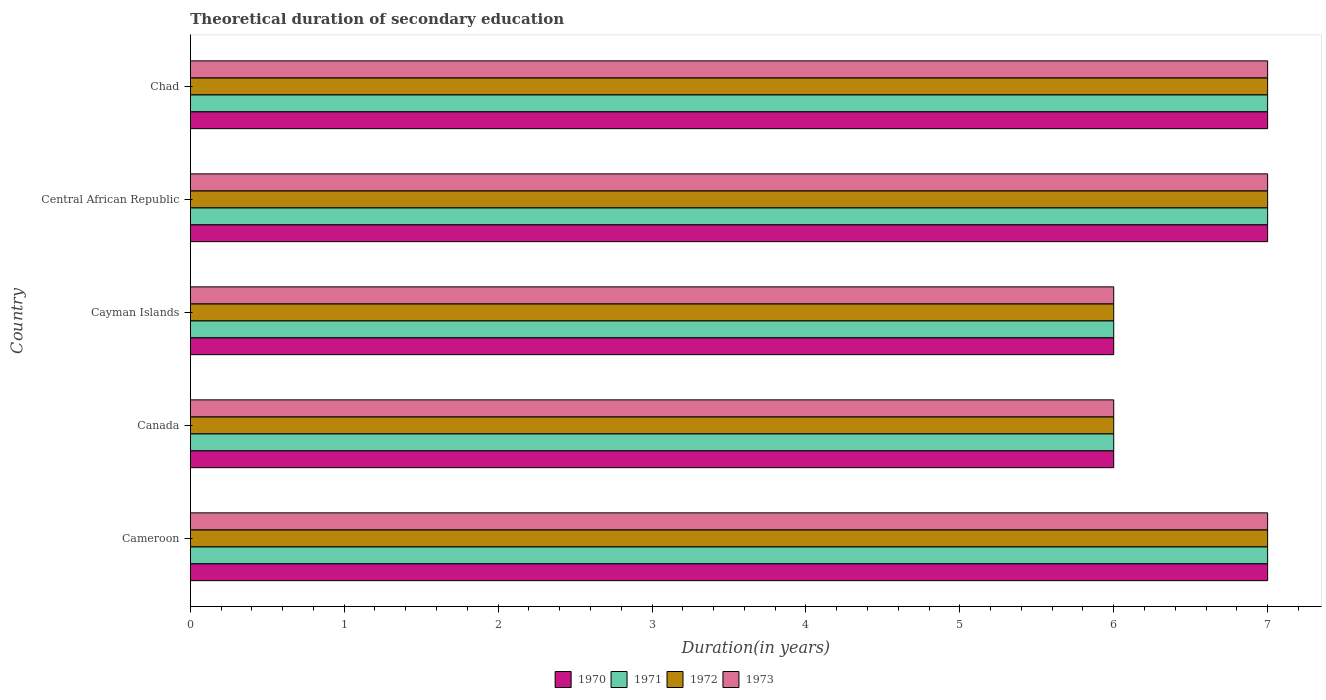How many bars are there on the 3rd tick from the bottom?
Offer a terse response. 4. What is the label of the 3rd group of bars from the top?
Provide a short and direct response. Cayman Islands. What is the total theoretical duration of secondary education in 1970 in Canada?
Offer a terse response. 6. In which country was the total theoretical duration of secondary education in 1971 maximum?
Make the answer very short. Cameroon. What is the ratio of the total theoretical duration of secondary education in 1972 in Central African Republic to that in Chad?
Your answer should be very brief. 1. Is the total theoretical duration of secondary education in 1972 in Canada less than that in Central African Republic?
Provide a succinct answer. Yes. Is the difference between the total theoretical duration of secondary education in 1971 in Canada and Chad greater than the difference between the total theoretical duration of secondary education in 1973 in Canada and Chad?
Give a very brief answer. No. What is the difference between the highest and the second highest total theoretical duration of secondary education in 1970?
Provide a succinct answer. 0. What is the difference between the highest and the lowest total theoretical duration of secondary education in 1970?
Offer a terse response. 1. In how many countries, is the total theoretical duration of secondary education in 1973 greater than the average total theoretical duration of secondary education in 1973 taken over all countries?
Your answer should be compact. 3. What does the 1st bar from the top in Canada represents?
Keep it short and to the point. 1973. What does the 3rd bar from the bottom in Cameroon represents?
Your response must be concise. 1972. Is it the case that in every country, the sum of the total theoretical duration of secondary education in 1971 and total theoretical duration of secondary education in 1970 is greater than the total theoretical duration of secondary education in 1972?
Give a very brief answer. Yes. How many bars are there?
Provide a succinct answer. 20. What is the difference between two consecutive major ticks on the X-axis?
Keep it short and to the point. 1. Does the graph contain any zero values?
Your answer should be very brief. No. What is the title of the graph?
Your answer should be very brief. Theoretical duration of secondary education. What is the label or title of the X-axis?
Ensure brevity in your answer.  Duration(in years). What is the Duration(in years) in 1970 in Cameroon?
Your response must be concise. 7. What is the Duration(in years) of 1971 in Cameroon?
Offer a terse response. 7. What is the Duration(in years) in 1970 in Canada?
Offer a terse response. 6. What is the Duration(in years) of 1973 in Canada?
Provide a succinct answer. 6. What is the Duration(in years) of 1970 in Central African Republic?
Offer a terse response. 7. What is the Duration(in years) of 1971 in Central African Republic?
Keep it short and to the point. 7. What is the Duration(in years) of 1970 in Chad?
Ensure brevity in your answer.  7. What is the Duration(in years) in 1973 in Chad?
Offer a very short reply. 7. Across all countries, what is the maximum Duration(in years) in 1972?
Provide a short and direct response. 7. Across all countries, what is the maximum Duration(in years) of 1973?
Offer a terse response. 7. Across all countries, what is the minimum Duration(in years) of 1970?
Offer a terse response. 6. Across all countries, what is the minimum Duration(in years) in 1971?
Offer a very short reply. 6. What is the total Duration(in years) of 1970 in the graph?
Offer a very short reply. 33. What is the total Duration(in years) of 1971 in the graph?
Ensure brevity in your answer.  33. What is the total Duration(in years) of 1973 in the graph?
Offer a terse response. 33. What is the difference between the Duration(in years) in 1971 in Cameroon and that in Canada?
Keep it short and to the point. 1. What is the difference between the Duration(in years) of 1972 in Cameroon and that in Canada?
Your answer should be very brief. 1. What is the difference between the Duration(in years) in 1970 in Cameroon and that in Cayman Islands?
Offer a terse response. 1. What is the difference between the Duration(in years) in 1971 in Cameroon and that in Cayman Islands?
Your answer should be compact. 1. What is the difference between the Duration(in years) of 1970 in Cameroon and that in Central African Republic?
Keep it short and to the point. 0. What is the difference between the Duration(in years) in 1972 in Cameroon and that in Chad?
Your response must be concise. 0. What is the difference between the Duration(in years) in 1973 in Cameroon and that in Chad?
Your answer should be very brief. 0. What is the difference between the Duration(in years) of 1970 in Canada and that in Central African Republic?
Keep it short and to the point. -1. What is the difference between the Duration(in years) of 1973 in Canada and that in Central African Republic?
Provide a short and direct response. -1. What is the difference between the Duration(in years) in 1971 in Cayman Islands and that in Central African Republic?
Make the answer very short. -1. What is the difference between the Duration(in years) of 1973 in Cayman Islands and that in Central African Republic?
Keep it short and to the point. -1. What is the difference between the Duration(in years) of 1972 in Cayman Islands and that in Chad?
Your answer should be very brief. -1. What is the difference between the Duration(in years) of 1973 in Cayman Islands and that in Chad?
Provide a succinct answer. -1. What is the difference between the Duration(in years) of 1970 in Central African Republic and that in Chad?
Your answer should be compact. 0. What is the difference between the Duration(in years) of 1972 in Central African Republic and that in Chad?
Ensure brevity in your answer.  0. What is the difference between the Duration(in years) in 1973 in Central African Republic and that in Chad?
Offer a terse response. 0. What is the difference between the Duration(in years) of 1970 in Cameroon and the Duration(in years) of 1971 in Canada?
Provide a short and direct response. 1. What is the difference between the Duration(in years) of 1970 in Cameroon and the Duration(in years) of 1972 in Canada?
Your answer should be very brief. 1. What is the difference between the Duration(in years) in 1970 in Cameroon and the Duration(in years) in 1973 in Canada?
Offer a very short reply. 1. What is the difference between the Duration(in years) of 1971 in Cameroon and the Duration(in years) of 1972 in Canada?
Ensure brevity in your answer.  1. What is the difference between the Duration(in years) of 1970 in Cameroon and the Duration(in years) of 1971 in Cayman Islands?
Give a very brief answer. 1. What is the difference between the Duration(in years) of 1970 in Cameroon and the Duration(in years) of 1972 in Cayman Islands?
Your answer should be compact. 1. What is the difference between the Duration(in years) of 1971 in Cameroon and the Duration(in years) of 1973 in Cayman Islands?
Keep it short and to the point. 1. What is the difference between the Duration(in years) in 1970 in Cameroon and the Duration(in years) in 1972 in Central African Republic?
Your response must be concise. 0. What is the difference between the Duration(in years) of 1971 in Cameroon and the Duration(in years) of 1973 in Central African Republic?
Give a very brief answer. 0. What is the difference between the Duration(in years) of 1972 in Cameroon and the Duration(in years) of 1973 in Central African Republic?
Offer a very short reply. 0. What is the difference between the Duration(in years) of 1970 in Cameroon and the Duration(in years) of 1971 in Chad?
Your response must be concise. 0. What is the difference between the Duration(in years) of 1971 in Cameroon and the Duration(in years) of 1972 in Chad?
Offer a terse response. 0. What is the difference between the Duration(in years) of 1971 in Cameroon and the Duration(in years) of 1973 in Chad?
Your answer should be very brief. 0. What is the difference between the Duration(in years) of 1972 in Cameroon and the Duration(in years) of 1973 in Chad?
Provide a short and direct response. 0. What is the difference between the Duration(in years) in 1970 in Canada and the Duration(in years) in 1972 in Cayman Islands?
Your answer should be compact. 0. What is the difference between the Duration(in years) of 1970 in Canada and the Duration(in years) of 1971 in Central African Republic?
Offer a very short reply. -1. What is the difference between the Duration(in years) in 1971 in Canada and the Duration(in years) in 1972 in Central African Republic?
Your response must be concise. -1. What is the difference between the Duration(in years) in 1971 in Canada and the Duration(in years) in 1973 in Central African Republic?
Keep it short and to the point. -1. What is the difference between the Duration(in years) of 1971 in Canada and the Duration(in years) of 1972 in Chad?
Provide a short and direct response. -1. What is the difference between the Duration(in years) in 1970 in Cayman Islands and the Duration(in years) in 1971 in Central African Republic?
Offer a terse response. -1. What is the difference between the Duration(in years) in 1970 in Cayman Islands and the Duration(in years) in 1972 in Central African Republic?
Provide a succinct answer. -1. What is the difference between the Duration(in years) in 1970 in Cayman Islands and the Duration(in years) in 1973 in Central African Republic?
Your answer should be very brief. -1. What is the difference between the Duration(in years) in 1971 in Cayman Islands and the Duration(in years) in 1972 in Central African Republic?
Your answer should be very brief. -1. What is the difference between the Duration(in years) of 1970 in Cayman Islands and the Duration(in years) of 1973 in Chad?
Offer a very short reply. -1. What is the difference between the Duration(in years) in 1971 in Cayman Islands and the Duration(in years) in 1972 in Chad?
Offer a terse response. -1. What is the difference between the Duration(in years) of 1972 in Cayman Islands and the Duration(in years) of 1973 in Chad?
Make the answer very short. -1. What is the difference between the Duration(in years) in 1970 in Central African Republic and the Duration(in years) in 1971 in Chad?
Your answer should be compact. 0. What is the difference between the Duration(in years) of 1971 in Central African Republic and the Duration(in years) of 1973 in Chad?
Provide a short and direct response. 0. What is the average Duration(in years) in 1971 per country?
Offer a terse response. 6.6. What is the average Duration(in years) of 1972 per country?
Give a very brief answer. 6.6. What is the difference between the Duration(in years) in 1970 and Duration(in years) in 1971 in Cameroon?
Your response must be concise. 0. What is the difference between the Duration(in years) of 1970 and Duration(in years) of 1972 in Cameroon?
Your response must be concise. 0. What is the difference between the Duration(in years) in 1970 and Duration(in years) in 1973 in Cameroon?
Give a very brief answer. 0. What is the difference between the Duration(in years) of 1970 and Duration(in years) of 1972 in Canada?
Give a very brief answer. 0. What is the difference between the Duration(in years) of 1970 and Duration(in years) of 1973 in Canada?
Offer a very short reply. 0. What is the difference between the Duration(in years) of 1971 and Duration(in years) of 1972 in Canada?
Offer a terse response. 0. What is the difference between the Duration(in years) in 1972 and Duration(in years) in 1973 in Canada?
Ensure brevity in your answer.  0. What is the difference between the Duration(in years) of 1970 and Duration(in years) of 1971 in Cayman Islands?
Give a very brief answer. 0. What is the difference between the Duration(in years) in 1971 and Duration(in years) in 1973 in Cayman Islands?
Make the answer very short. 0. What is the difference between the Duration(in years) of 1970 and Duration(in years) of 1971 in Central African Republic?
Offer a terse response. 0. What is the difference between the Duration(in years) of 1970 and Duration(in years) of 1972 in Central African Republic?
Ensure brevity in your answer.  0. What is the difference between the Duration(in years) of 1970 and Duration(in years) of 1973 in Central African Republic?
Keep it short and to the point. 0. What is the difference between the Duration(in years) of 1971 and Duration(in years) of 1973 in Central African Republic?
Give a very brief answer. 0. What is the difference between the Duration(in years) of 1972 and Duration(in years) of 1973 in Central African Republic?
Give a very brief answer. 0. What is the difference between the Duration(in years) of 1970 and Duration(in years) of 1971 in Chad?
Your answer should be compact. 0. What is the difference between the Duration(in years) in 1970 and Duration(in years) in 1972 in Chad?
Give a very brief answer. 0. What is the difference between the Duration(in years) of 1971 and Duration(in years) of 1972 in Chad?
Your answer should be very brief. 0. What is the difference between the Duration(in years) of 1972 and Duration(in years) of 1973 in Chad?
Offer a terse response. 0. What is the ratio of the Duration(in years) of 1972 in Cameroon to that in Canada?
Your response must be concise. 1.17. What is the ratio of the Duration(in years) of 1973 in Cameroon to that in Canada?
Provide a succinct answer. 1.17. What is the ratio of the Duration(in years) of 1970 in Cameroon to that in Cayman Islands?
Give a very brief answer. 1.17. What is the ratio of the Duration(in years) in 1972 in Cameroon to that in Central African Republic?
Offer a very short reply. 1. What is the ratio of the Duration(in years) in 1972 in Cameroon to that in Chad?
Offer a terse response. 1. What is the ratio of the Duration(in years) of 1972 in Canada to that in Cayman Islands?
Give a very brief answer. 1. What is the ratio of the Duration(in years) of 1970 in Canada to that in Central African Republic?
Offer a very short reply. 0.86. What is the ratio of the Duration(in years) in 1971 in Canada to that in Central African Republic?
Provide a short and direct response. 0.86. What is the ratio of the Duration(in years) of 1972 in Canada to that in Central African Republic?
Offer a very short reply. 0.86. What is the ratio of the Duration(in years) in 1972 in Canada to that in Chad?
Offer a terse response. 0.86. What is the ratio of the Duration(in years) in 1971 in Cayman Islands to that in Central African Republic?
Ensure brevity in your answer.  0.86. What is the ratio of the Duration(in years) in 1970 in Cayman Islands to that in Chad?
Make the answer very short. 0.86. What is the ratio of the Duration(in years) in 1971 in Cayman Islands to that in Chad?
Your response must be concise. 0.86. What is the ratio of the Duration(in years) of 1972 in Cayman Islands to that in Chad?
Give a very brief answer. 0.86. What is the ratio of the Duration(in years) in 1973 in Cayman Islands to that in Chad?
Your answer should be very brief. 0.86. What is the ratio of the Duration(in years) of 1971 in Central African Republic to that in Chad?
Offer a terse response. 1. What is the difference between the highest and the second highest Duration(in years) of 1971?
Offer a very short reply. 0. What is the difference between the highest and the second highest Duration(in years) in 1972?
Make the answer very short. 0. What is the difference between the highest and the lowest Duration(in years) in 1970?
Give a very brief answer. 1. What is the difference between the highest and the lowest Duration(in years) in 1973?
Make the answer very short. 1. 